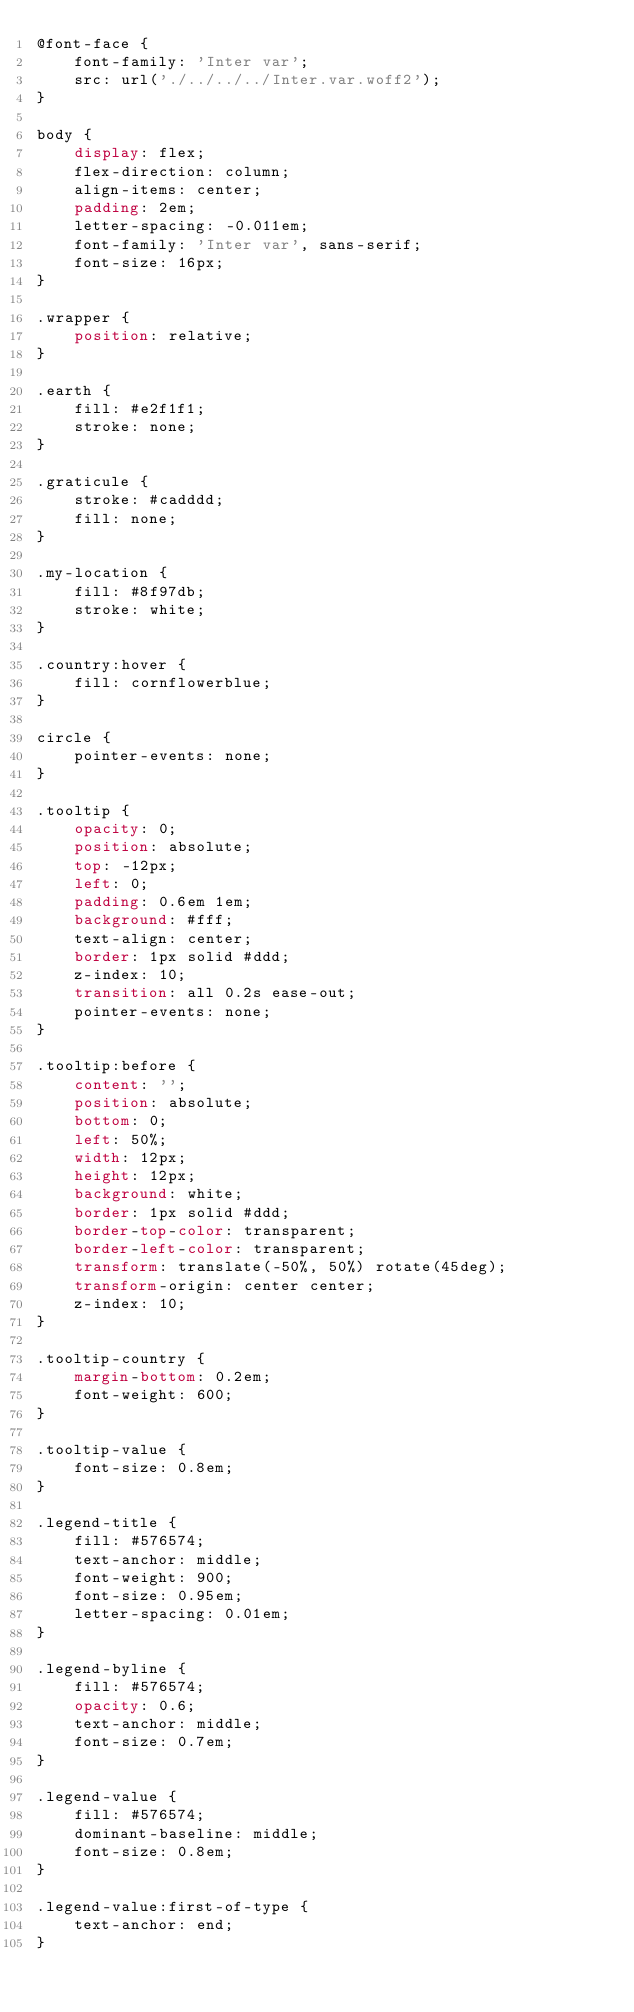Convert code to text. <code><loc_0><loc_0><loc_500><loc_500><_CSS_>@font-face {
    font-family: 'Inter var';
    src: url('./../../../Inter.var.woff2');
}

body {
    display: flex;
    flex-direction: column;
    align-items: center;
    padding: 2em;
    letter-spacing: -0.011em;
    font-family: 'Inter var', sans-serif;
    font-size: 16px;
}

.wrapper {
    position: relative;
}

.earth {
    fill: #e2f1f1;
    stroke: none;
}

.graticule {
    stroke: #cadddd;
    fill: none;
}

.my-location {
    fill: #8f97db;
    stroke: white;
}

.country:hover {
    fill: cornflowerblue;
}

circle {
    pointer-events: none;
}

.tooltip {
    opacity: 0;
    position: absolute;
    top: -12px;
    left: 0;
    padding: 0.6em 1em;
    background: #fff;
    text-align: center;
    border: 1px solid #ddd;
    z-index: 10;
    transition: all 0.2s ease-out;
    pointer-events: none;
}

.tooltip:before {
    content: '';
    position: absolute;
    bottom: 0;
    left: 50%;
    width: 12px;
    height: 12px;
    background: white;
    border: 1px solid #ddd;
    border-top-color: transparent;
    border-left-color: transparent;
    transform: translate(-50%, 50%) rotate(45deg);
    transform-origin: center center;
    z-index: 10;
}

.tooltip-country {
    margin-bottom: 0.2em;
    font-weight: 600;
}

.tooltip-value {
    font-size: 0.8em;
}

.legend-title {
    fill: #576574;
    text-anchor: middle;
    font-weight: 900;
    font-size: 0.95em;
    letter-spacing: 0.01em;
}

.legend-byline {
    fill: #576574;
    opacity: 0.6;
    text-anchor: middle;
    font-size: 0.7em;
}

.legend-value {
    fill: #576574;
    dominant-baseline: middle;
    font-size: 0.8em;
}

.legend-value:first-of-type {
    text-anchor: end;
}</code> 